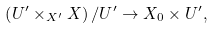Convert formula to latex. <formula><loc_0><loc_0><loc_500><loc_500>\left ( U ^ { \prime } \times _ { X ^ { \prime } } X \right ) / U ^ { \prime } \rightarrow X _ { 0 } \times U ^ { \prime } ,</formula> 